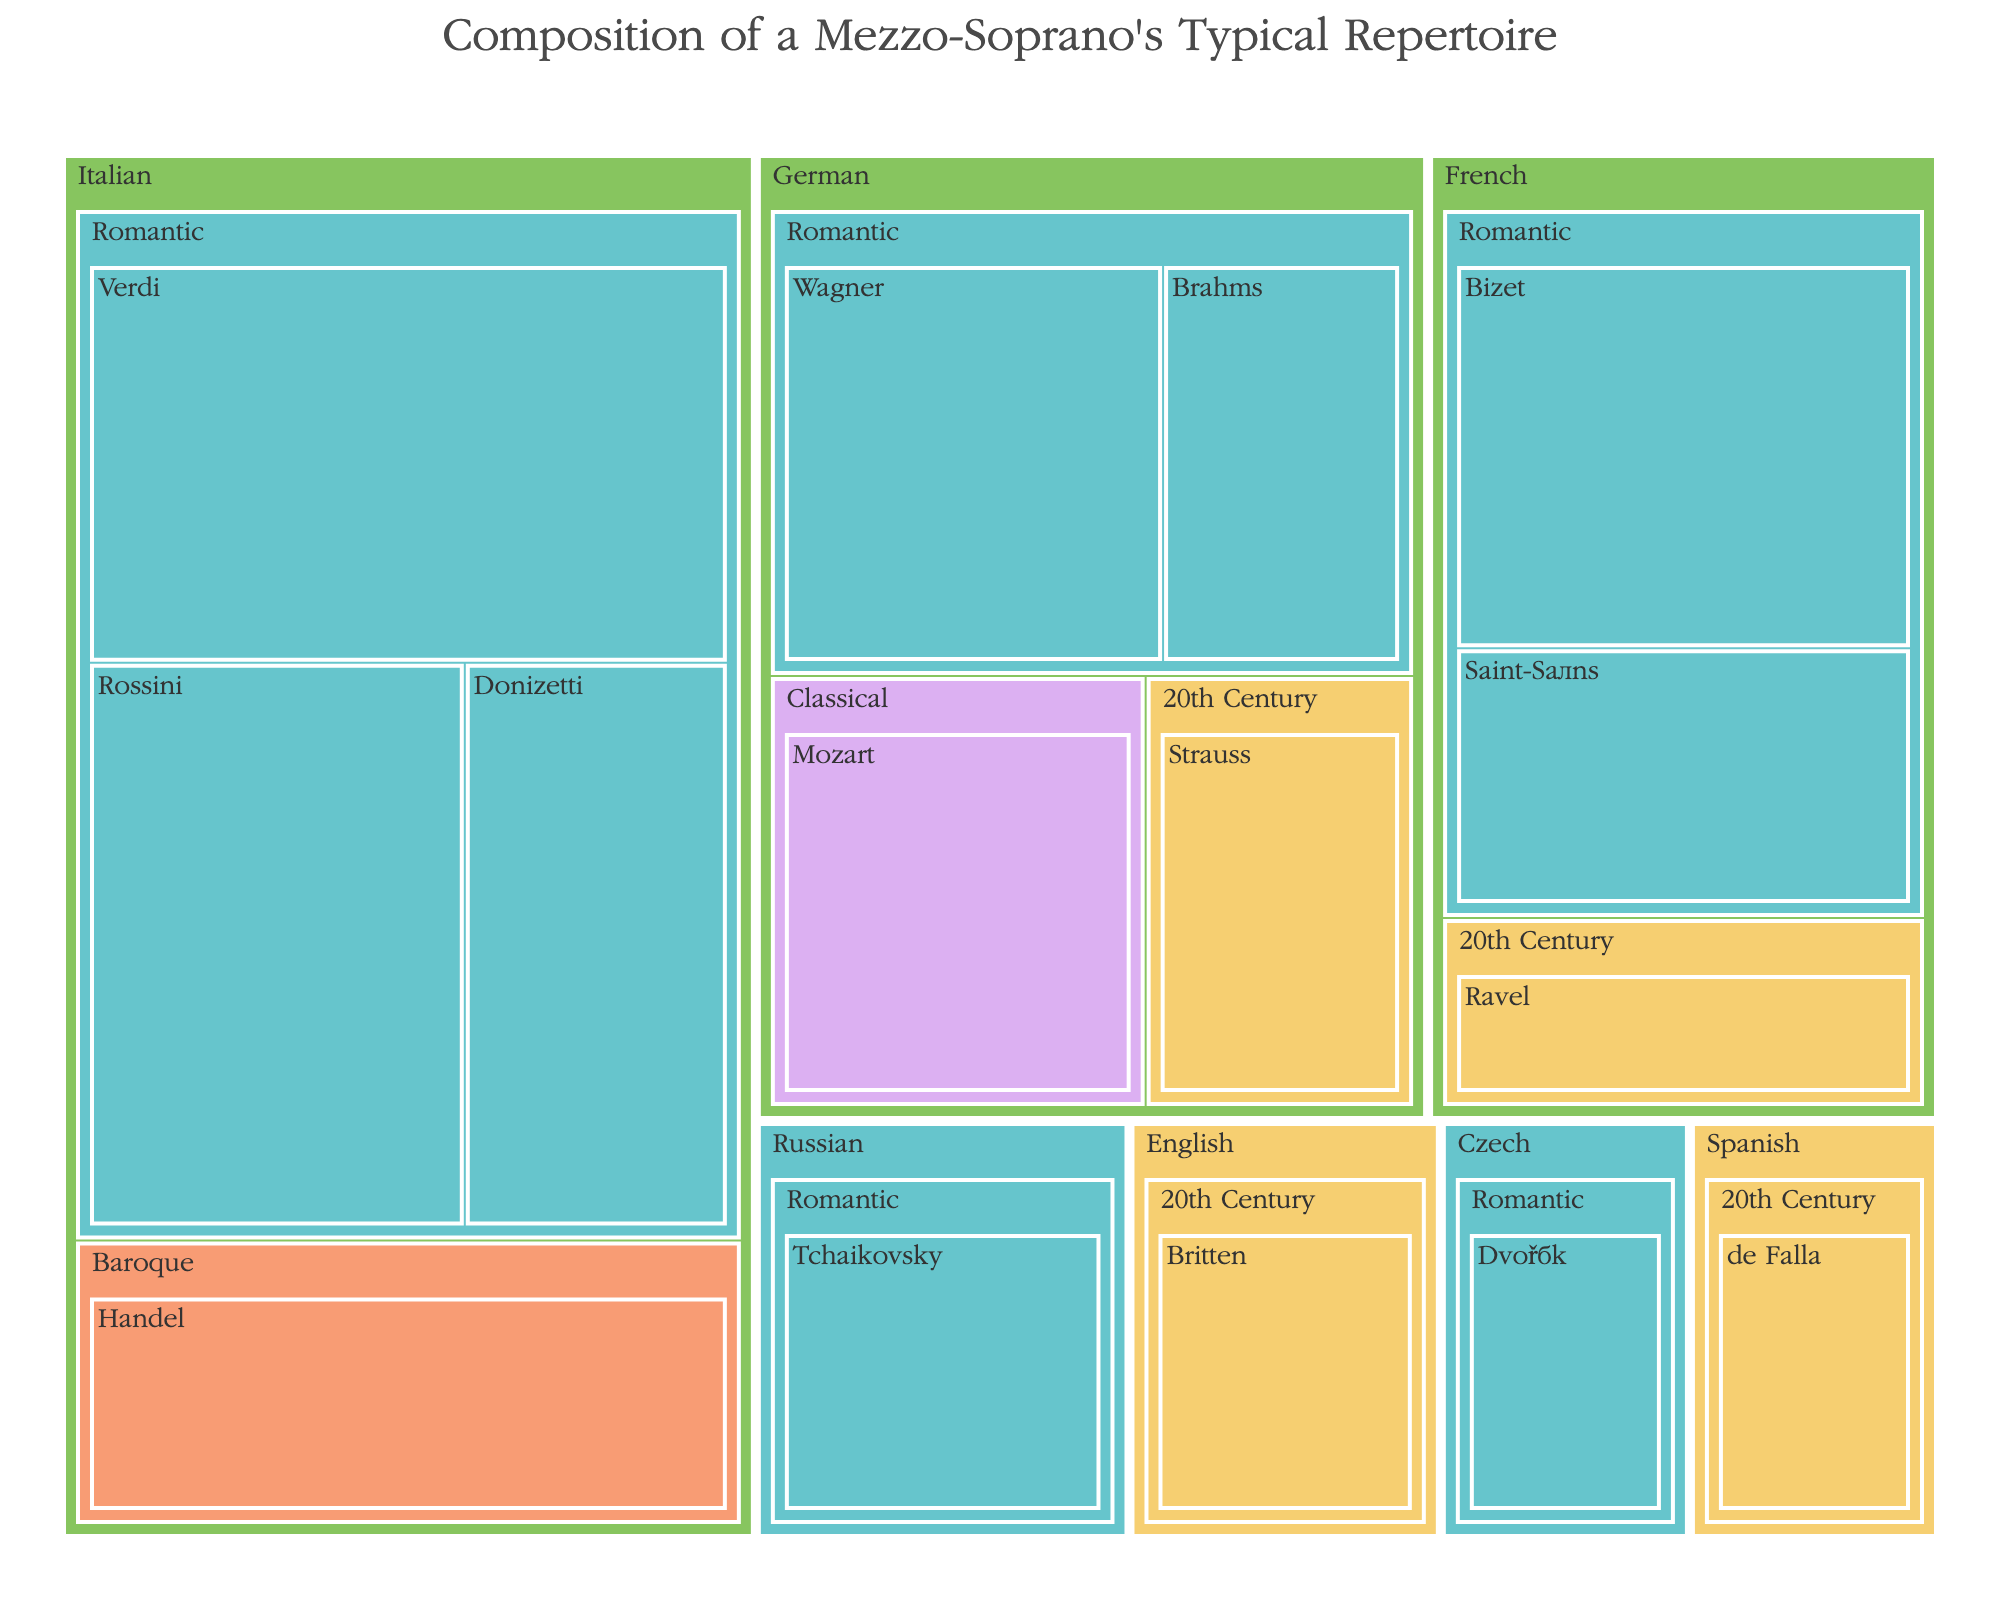what is the largest percentage allocation for a single composer? To find the highest percentage allocated to a single composer, inspect the values under each composer's name in the treemap. The largest value is clearly “Verdi” under “Romantic Italian” with 12%.
Answer: 12% Which language has the most composers represented in the repertoire? Look across the treemap and count the number of unique composer names under each language section. Italian has four composers, French has three, German has three, Russian has one, Czech has one, English has one, and Spanish has one. Therefore, Italian has the most composers represented.
Answer: Italian What is the total percentage contribution of the Romantic era across all languages? To get the total percentage contribution of the Romantic era, sum the percentages of all Romantic era composers from each language: 12 (Verdi) + 10 (Rossini) + 7 (Donizetti) + 9 (Bizet) + 6 (Saint-Saëns) + 8 (Wagner) + 5 (Brahms) + 6 (Tchaikovsky) + 4 (Dvořák) = 67%.
Answer: 67% What's the difference in the total percentage between Italian and French compositions? Sum the percentages allocated to all Italian composers (8 + 12 + 10 + 7 = 37%) and all French composers (9 + 6 + 4 = 19%). The difference is 37% - 19% = 18%.
Answer: 18% Which language has the smallest representation in the 20th century? Observe the 20th century section under each language: English (5%, Britten), Spanish (4%, de Falla), German (5%, Strauss), French (4%, Ravel). Both Spanish and French have the smallest representation with 4%.
Answer: Spanish and French How many eras are represented in the German repertoire? Find the German section in the treemap and identify the unique eras listed: Romantic (Wagner, Brahms) and Classical (Mozart), and 20th Century (Strauss). That gives us three unique eras.
Answer: Three eras Which composer in the Romantic era has the lowest percentage representation? In the treemap, look under each Romantic era section for the lowest value: Donizetti (7%, Italian), Saint-Saëns (6%, French), Brahms (5%, German), Tchaikovsky (6%, Russian), Dvořák (4%, Czech). Dvořák has the lowest representation with 4%.
Answer: Dvořák What percentage is allocated to the Baroque era? Locate the Baroque era section in the treemap, which is listed under Italian. The only composer listed there is Handel with a percentage of 8%.
Answer: 8% Which era is the most represented in the repertoire? Sum the percentages of composers under each era: Baroque (8%, Handel), Classical (7%, Mozart), Romantic (67%, various composers), 20th Century (5%+4%+5%+4%=18%). The Romantic era has the highest sum at 67%.
Answer: Romantic What is the combined percentage of compositions by Wagner and Brahms? Find the percentages allocated to Wagner (8%) and Brahms (5%) in the German Romantic section. Their combined percentage is 8% + 5% = 13%.
Answer: 13% 